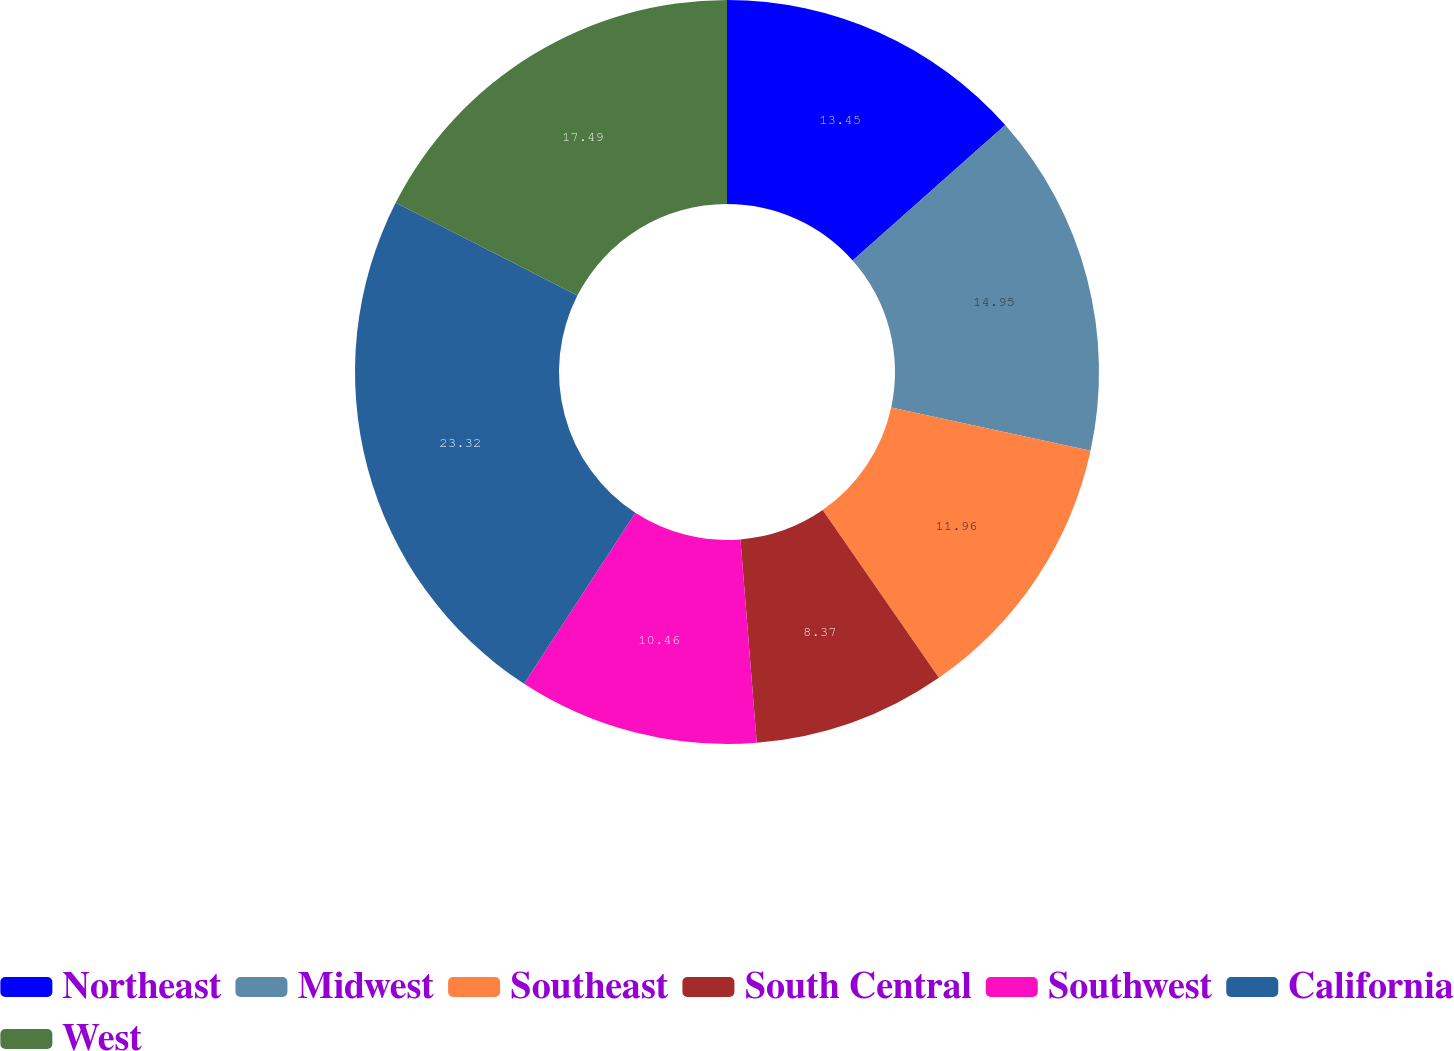Convert chart to OTSL. <chart><loc_0><loc_0><loc_500><loc_500><pie_chart><fcel>Northeast<fcel>Midwest<fcel>Southeast<fcel>South Central<fcel>Southwest<fcel>California<fcel>West<nl><fcel>13.45%<fcel>14.95%<fcel>11.96%<fcel>8.37%<fcel>10.46%<fcel>23.33%<fcel>17.49%<nl></chart> 